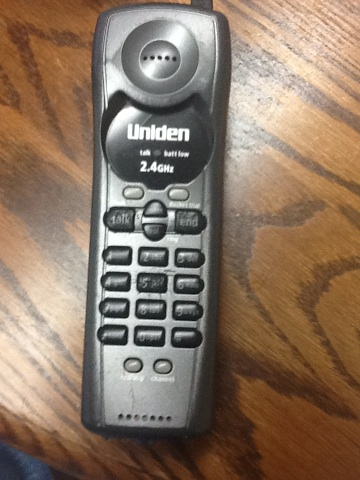What is it? Maybe it's not ready to go. Trying to get this to work. What? Oh the thing? Yeah. from Vizwiz The object you’re referring to is a Uniden 2.4 GHz cordless telephone. This specific model is an older type of handheld phone, typically used in home settings and is distinguishable by its elongated design and numeric keypad. 